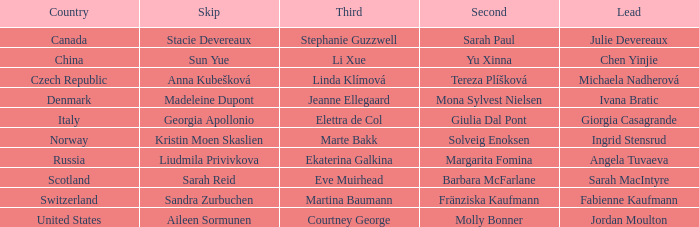What omission has switzerland as the nation? Sandra Zurbuchen. 